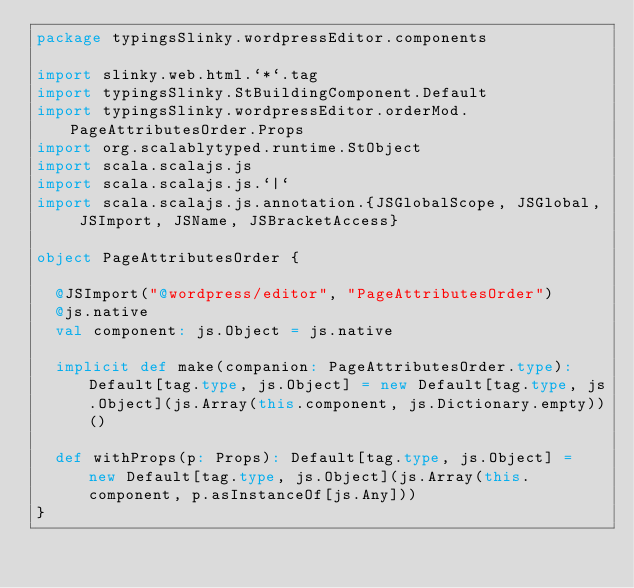Convert code to text. <code><loc_0><loc_0><loc_500><loc_500><_Scala_>package typingsSlinky.wordpressEditor.components

import slinky.web.html.`*`.tag
import typingsSlinky.StBuildingComponent.Default
import typingsSlinky.wordpressEditor.orderMod.PageAttributesOrder.Props
import org.scalablytyped.runtime.StObject
import scala.scalajs.js
import scala.scalajs.js.`|`
import scala.scalajs.js.annotation.{JSGlobalScope, JSGlobal, JSImport, JSName, JSBracketAccess}

object PageAttributesOrder {
  
  @JSImport("@wordpress/editor", "PageAttributesOrder")
  @js.native
  val component: js.Object = js.native
  
  implicit def make(companion: PageAttributesOrder.type): Default[tag.type, js.Object] = new Default[tag.type, js.Object](js.Array(this.component, js.Dictionary.empty))()
  
  def withProps(p: Props): Default[tag.type, js.Object] = new Default[tag.type, js.Object](js.Array(this.component, p.asInstanceOf[js.Any]))
}
</code> 